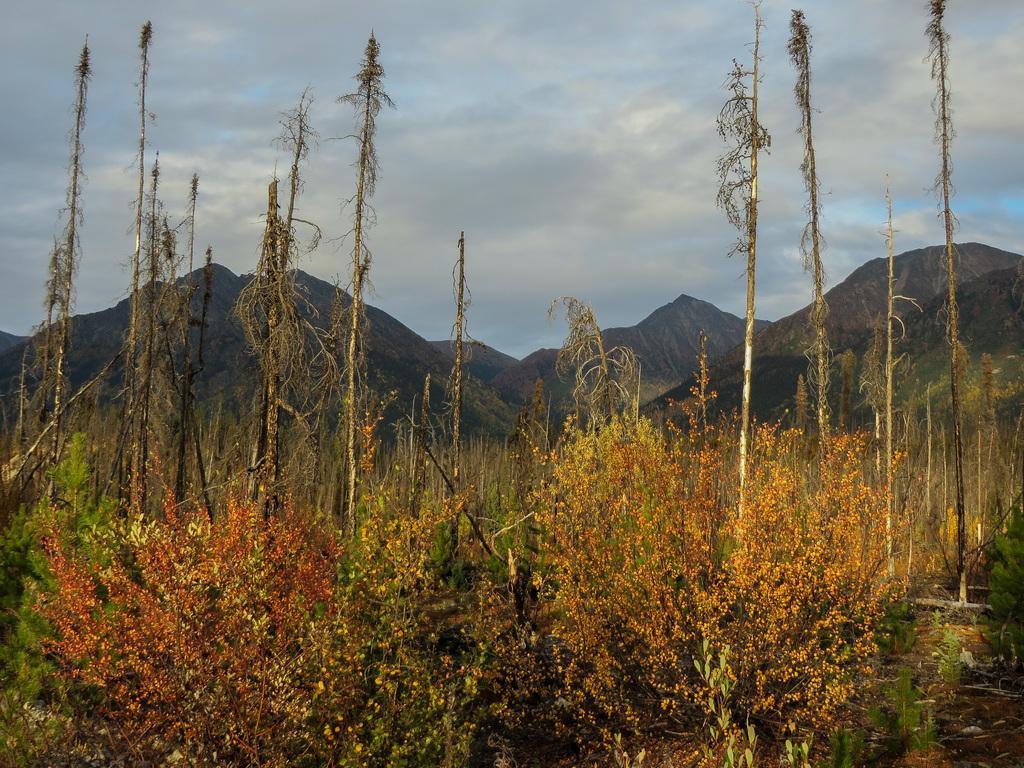How would you summarize this image in a sentence or two? In this image we can see trees and plants. In the background there are hills, sky and clouds. 